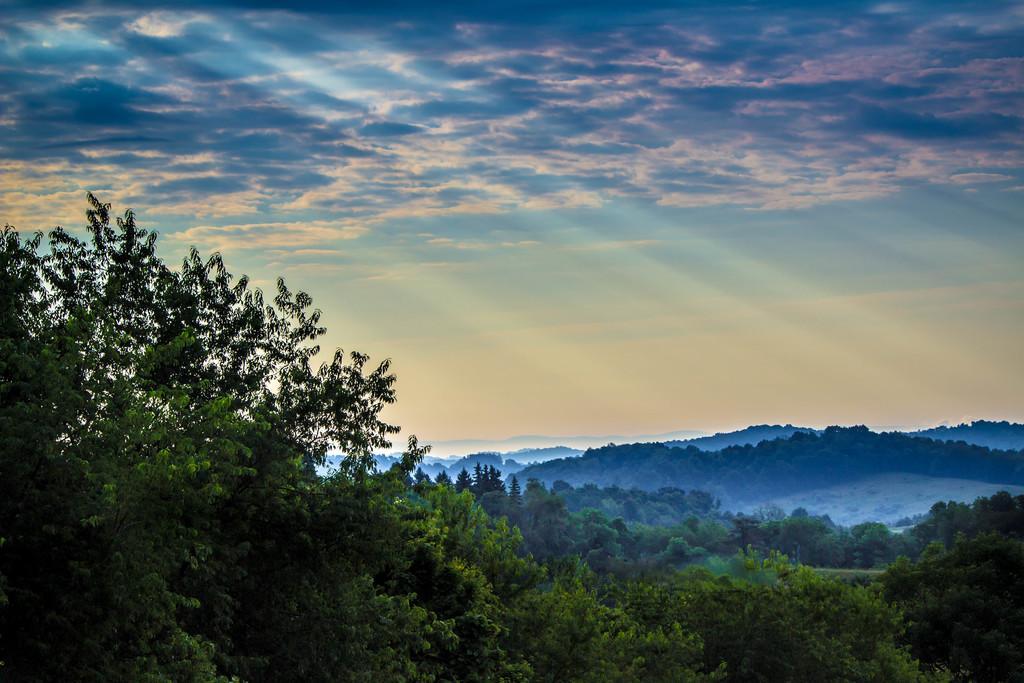Could you give a brief overview of what you see in this image? In this image there is the sky, there are clouds in the sky, there are mountains, there are trees, there are mountains truncated towards the right of the image, there are trees truncated towards the right of the image, there are trees truncated towards the left of the image, there are trees truncated towards the bottom of the image. 